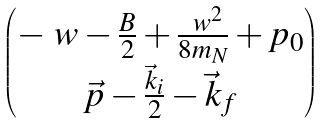<formula> <loc_0><loc_0><loc_500><loc_500>\begin{pmatrix} - \ w - \frac { B } { 2 } + \frac { \ w ^ { 2 } } { 8 m _ { N } } + p _ { 0 } \\ \vec { p } - \frac { \vec { k } _ { i } } { 2 } - \vec { k } _ { f } \end{pmatrix}</formula> 